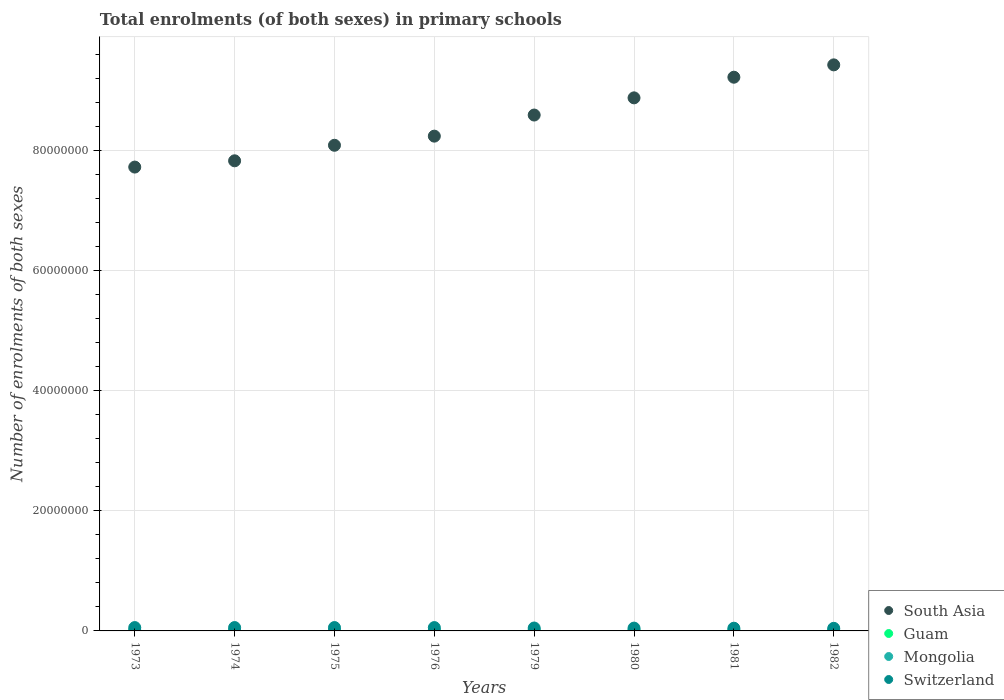How many different coloured dotlines are there?
Keep it short and to the point. 4. Is the number of dotlines equal to the number of legend labels?
Your answer should be very brief. Yes. What is the number of enrolments in primary schools in Switzerland in 1979?
Make the answer very short. 4.86e+05. Across all years, what is the maximum number of enrolments in primary schools in Switzerland?
Provide a short and direct response. 5.62e+05. Across all years, what is the minimum number of enrolments in primary schools in South Asia?
Provide a succinct answer. 7.73e+07. In which year was the number of enrolments in primary schools in Guam maximum?
Offer a very short reply. 1976. What is the total number of enrolments in primary schools in Guam in the graph?
Provide a short and direct response. 1.47e+05. What is the difference between the number of enrolments in primary schools in Switzerland in 1979 and that in 1981?
Your answer should be compact. 3.50e+04. What is the difference between the number of enrolments in primary schools in Guam in 1973 and the number of enrolments in primary schools in Switzerland in 1982?
Offer a very short reply. -4.16e+05. What is the average number of enrolments in primary schools in Guam per year?
Provide a succinct answer. 1.84e+04. In the year 1975, what is the difference between the number of enrolments in primary schools in Guam and number of enrolments in primary schools in Mongolia?
Ensure brevity in your answer.  -1.10e+05. What is the ratio of the number of enrolments in primary schools in Switzerland in 1974 to that in 1979?
Ensure brevity in your answer.  1.16. Is the number of enrolments in primary schools in Guam in 1974 less than that in 1976?
Your answer should be very brief. Yes. Is the difference between the number of enrolments in primary schools in Guam in 1974 and 1981 greater than the difference between the number of enrolments in primary schools in Mongolia in 1974 and 1981?
Offer a very short reply. Yes. What is the difference between the highest and the second highest number of enrolments in primary schools in Switzerland?
Your answer should be very brief. 128. What is the difference between the highest and the lowest number of enrolments in primary schools in Switzerland?
Offer a very short reply. 1.27e+05. In how many years, is the number of enrolments in primary schools in Guam greater than the average number of enrolments in primary schools in Guam taken over all years?
Offer a very short reply. 3. Is the sum of the number of enrolments in primary schools in Guam in 1973 and 1975 greater than the maximum number of enrolments in primary schools in Mongolia across all years?
Make the answer very short. No. Is it the case that in every year, the sum of the number of enrolments in primary schools in Guam and number of enrolments in primary schools in Mongolia  is greater than the sum of number of enrolments in primary schools in South Asia and number of enrolments in primary schools in Switzerland?
Your response must be concise. No. Is the number of enrolments in primary schools in Guam strictly less than the number of enrolments in primary schools in Switzerland over the years?
Offer a very short reply. Yes. Does the graph contain any zero values?
Your response must be concise. No. Does the graph contain grids?
Make the answer very short. Yes. Where does the legend appear in the graph?
Ensure brevity in your answer.  Bottom right. How many legend labels are there?
Ensure brevity in your answer.  4. What is the title of the graph?
Provide a short and direct response. Total enrolments (of both sexes) in primary schools. Does "European Union" appear as one of the legend labels in the graph?
Give a very brief answer. No. What is the label or title of the Y-axis?
Ensure brevity in your answer.  Number of enrolments of both sexes. What is the Number of enrolments of both sexes in South Asia in 1973?
Your response must be concise. 7.73e+07. What is the Number of enrolments of both sexes of Guam in 1973?
Your answer should be very brief. 1.87e+04. What is the Number of enrolments of both sexes in Mongolia in 1973?
Give a very brief answer. 1.25e+05. What is the Number of enrolments of both sexes in Switzerland in 1973?
Your response must be concise. 5.58e+05. What is the Number of enrolments of both sexes in South Asia in 1974?
Provide a succinct answer. 7.83e+07. What is the Number of enrolments of both sexes of Guam in 1974?
Provide a succinct answer. 1.85e+04. What is the Number of enrolments of both sexes in Mongolia in 1974?
Keep it short and to the point. 1.27e+05. What is the Number of enrolments of both sexes in Switzerland in 1974?
Provide a short and direct response. 5.62e+05. What is the Number of enrolments of both sexes in South Asia in 1975?
Provide a short and direct response. 8.09e+07. What is the Number of enrolments of both sexes in Guam in 1975?
Provide a succinct answer. 1.78e+04. What is the Number of enrolments of both sexes of Mongolia in 1975?
Provide a short and direct response. 1.28e+05. What is the Number of enrolments of both sexes in Switzerland in 1975?
Keep it short and to the point. 5.62e+05. What is the Number of enrolments of both sexes in South Asia in 1976?
Ensure brevity in your answer.  8.24e+07. What is the Number of enrolments of both sexes in Guam in 1976?
Provide a succinct answer. 2.02e+04. What is the Number of enrolments of both sexes of Mongolia in 1976?
Your response must be concise. 1.30e+05. What is the Number of enrolments of both sexes of Switzerland in 1976?
Your answer should be very brief. 5.57e+05. What is the Number of enrolments of both sexes in South Asia in 1979?
Provide a short and direct response. 8.59e+07. What is the Number of enrolments of both sexes in Guam in 1979?
Provide a succinct answer. 1.77e+04. What is the Number of enrolments of both sexes of Mongolia in 1979?
Provide a succinct answer. 1.39e+05. What is the Number of enrolments of both sexes in Switzerland in 1979?
Provide a short and direct response. 4.86e+05. What is the Number of enrolments of both sexes of South Asia in 1980?
Provide a short and direct response. 8.88e+07. What is the Number of enrolments of both sexes in Guam in 1980?
Your answer should be compact. 1.80e+04. What is the Number of enrolments of both sexes in Mongolia in 1980?
Your answer should be compact. 1.41e+05. What is the Number of enrolments of both sexes of Switzerland in 1980?
Your answer should be compact. 4.69e+05. What is the Number of enrolments of both sexes of South Asia in 1981?
Give a very brief answer. 9.22e+07. What is the Number of enrolments of both sexes in Guam in 1981?
Your response must be concise. 1.81e+04. What is the Number of enrolments of both sexes of Mongolia in 1981?
Offer a terse response. 1.45e+05. What is the Number of enrolments of both sexes of Switzerland in 1981?
Your response must be concise. 4.51e+05. What is the Number of enrolments of both sexes in South Asia in 1982?
Provide a short and direct response. 9.43e+07. What is the Number of enrolments of both sexes in Guam in 1982?
Offer a terse response. 1.79e+04. What is the Number of enrolments of both sexes of Mongolia in 1982?
Ensure brevity in your answer.  1.46e+05. What is the Number of enrolments of both sexes of Switzerland in 1982?
Make the answer very short. 4.34e+05. Across all years, what is the maximum Number of enrolments of both sexes in South Asia?
Provide a succinct answer. 9.43e+07. Across all years, what is the maximum Number of enrolments of both sexes of Guam?
Ensure brevity in your answer.  2.02e+04. Across all years, what is the maximum Number of enrolments of both sexes of Mongolia?
Provide a succinct answer. 1.46e+05. Across all years, what is the maximum Number of enrolments of both sexes in Switzerland?
Offer a very short reply. 5.62e+05. Across all years, what is the minimum Number of enrolments of both sexes of South Asia?
Your answer should be very brief. 7.73e+07. Across all years, what is the minimum Number of enrolments of both sexes of Guam?
Offer a very short reply. 1.77e+04. Across all years, what is the minimum Number of enrolments of both sexes in Mongolia?
Make the answer very short. 1.25e+05. Across all years, what is the minimum Number of enrolments of both sexes of Switzerland?
Offer a very short reply. 4.34e+05. What is the total Number of enrolments of both sexes of South Asia in the graph?
Offer a terse response. 6.80e+08. What is the total Number of enrolments of both sexes in Guam in the graph?
Keep it short and to the point. 1.47e+05. What is the total Number of enrolments of both sexes in Mongolia in the graph?
Your answer should be very brief. 1.08e+06. What is the total Number of enrolments of both sexes of Switzerland in the graph?
Ensure brevity in your answer.  4.08e+06. What is the difference between the Number of enrolments of both sexes in South Asia in 1973 and that in 1974?
Offer a terse response. -1.05e+06. What is the difference between the Number of enrolments of both sexes in Guam in 1973 and that in 1974?
Offer a terse response. 196. What is the difference between the Number of enrolments of both sexes in Mongolia in 1973 and that in 1974?
Give a very brief answer. -1900. What is the difference between the Number of enrolments of both sexes of Switzerland in 1973 and that in 1974?
Your answer should be very brief. -3917. What is the difference between the Number of enrolments of both sexes in South Asia in 1973 and that in 1975?
Your answer should be very brief. -3.63e+06. What is the difference between the Number of enrolments of both sexes of Guam in 1973 and that in 1975?
Your answer should be very brief. 862. What is the difference between the Number of enrolments of both sexes of Mongolia in 1973 and that in 1975?
Offer a very short reply. -2786. What is the difference between the Number of enrolments of both sexes of Switzerland in 1973 and that in 1975?
Offer a terse response. -3789. What is the difference between the Number of enrolments of both sexes of South Asia in 1973 and that in 1976?
Provide a short and direct response. -5.15e+06. What is the difference between the Number of enrolments of both sexes of Guam in 1973 and that in 1976?
Make the answer very short. -1542. What is the difference between the Number of enrolments of both sexes of Mongolia in 1973 and that in 1976?
Your answer should be very brief. -4602. What is the difference between the Number of enrolments of both sexes of Switzerland in 1973 and that in 1976?
Your answer should be very brief. 971. What is the difference between the Number of enrolments of both sexes of South Asia in 1973 and that in 1979?
Your response must be concise. -8.67e+06. What is the difference between the Number of enrolments of both sexes in Guam in 1973 and that in 1979?
Offer a very short reply. 929. What is the difference between the Number of enrolments of both sexes of Mongolia in 1973 and that in 1979?
Give a very brief answer. -1.35e+04. What is the difference between the Number of enrolments of both sexes of Switzerland in 1973 and that in 1979?
Offer a very short reply. 7.20e+04. What is the difference between the Number of enrolments of both sexes of South Asia in 1973 and that in 1980?
Your response must be concise. -1.15e+07. What is the difference between the Number of enrolments of both sexes of Guam in 1973 and that in 1980?
Offer a terse response. 636. What is the difference between the Number of enrolments of both sexes in Mongolia in 1973 and that in 1980?
Offer a very short reply. -1.61e+04. What is the difference between the Number of enrolments of both sexes in Switzerland in 1973 and that in 1980?
Your response must be concise. 8.93e+04. What is the difference between the Number of enrolments of both sexes of South Asia in 1973 and that in 1981?
Keep it short and to the point. -1.50e+07. What is the difference between the Number of enrolments of both sexes of Guam in 1973 and that in 1981?
Provide a short and direct response. 580. What is the difference between the Number of enrolments of both sexes of Switzerland in 1973 and that in 1981?
Provide a succinct answer. 1.07e+05. What is the difference between the Number of enrolments of both sexes in South Asia in 1973 and that in 1982?
Offer a terse response. -1.70e+07. What is the difference between the Number of enrolments of both sexes in Guam in 1973 and that in 1982?
Your answer should be compact. 728. What is the difference between the Number of enrolments of both sexes of Mongolia in 1973 and that in 1982?
Give a very brief answer. -2.13e+04. What is the difference between the Number of enrolments of both sexes in Switzerland in 1973 and that in 1982?
Ensure brevity in your answer.  1.24e+05. What is the difference between the Number of enrolments of both sexes of South Asia in 1974 and that in 1975?
Provide a succinct answer. -2.59e+06. What is the difference between the Number of enrolments of both sexes in Guam in 1974 and that in 1975?
Offer a very short reply. 666. What is the difference between the Number of enrolments of both sexes in Mongolia in 1974 and that in 1975?
Your answer should be very brief. -886. What is the difference between the Number of enrolments of both sexes of Switzerland in 1974 and that in 1975?
Ensure brevity in your answer.  128. What is the difference between the Number of enrolments of both sexes in South Asia in 1974 and that in 1976?
Give a very brief answer. -4.11e+06. What is the difference between the Number of enrolments of both sexes of Guam in 1974 and that in 1976?
Provide a short and direct response. -1738. What is the difference between the Number of enrolments of both sexes of Mongolia in 1974 and that in 1976?
Provide a succinct answer. -2702. What is the difference between the Number of enrolments of both sexes in Switzerland in 1974 and that in 1976?
Provide a succinct answer. 4888. What is the difference between the Number of enrolments of both sexes in South Asia in 1974 and that in 1979?
Offer a very short reply. -7.62e+06. What is the difference between the Number of enrolments of both sexes of Guam in 1974 and that in 1979?
Your response must be concise. 733. What is the difference between the Number of enrolments of both sexes of Mongolia in 1974 and that in 1979?
Ensure brevity in your answer.  -1.16e+04. What is the difference between the Number of enrolments of both sexes of Switzerland in 1974 and that in 1979?
Provide a short and direct response. 7.59e+04. What is the difference between the Number of enrolments of both sexes in South Asia in 1974 and that in 1980?
Offer a terse response. -1.05e+07. What is the difference between the Number of enrolments of both sexes of Guam in 1974 and that in 1980?
Offer a very short reply. 440. What is the difference between the Number of enrolments of both sexes in Mongolia in 1974 and that in 1980?
Offer a very short reply. -1.42e+04. What is the difference between the Number of enrolments of both sexes of Switzerland in 1974 and that in 1980?
Make the answer very short. 9.32e+04. What is the difference between the Number of enrolments of both sexes of South Asia in 1974 and that in 1981?
Provide a succinct answer. -1.39e+07. What is the difference between the Number of enrolments of both sexes in Guam in 1974 and that in 1981?
Your answer should be compact. 384. What is the difference between the Number of enrolments of both sexes of Mongolia in 1974 and that in 1981?
Provide a succinct answer. -1.81e+04. What is the difference between the Number of enrolments of both sexes in Switzerland in 1974 and that in 1981?
Your answer should be very brief. 1.11e+05. What is the difference between the Number of enrolments of both sexes of South Asia in 1974 and that in 1982?
Offer a terse response. -1.60e+07. What is the difference between the Number of enrolments of both sexes of Guam in 1974 and that in 1982?
Offer a terse response. 532. What is the difference between the Number of enrolments of both sexes of Mongolia in 1974 and that in 1982?
Provide a succinct answer. -1.94e+04. What is the difference between the Number of enrolments of both sexes in Switzerland in 1974 and that in 1982?
Provide a short and direct response. 1.27e+05. What is the difference between the Number of enrolments of both sexes in South Asia in 1975 and that in 1976?
Provide a short and direct response. -1.52e+06. What is the difference between the Number of enrolments of both sexes of Guam in 1975 and that in 1976?
Provide a succinct answer. -2404. What is the difference between the Number of enrolments of both sexes of Mongolia in 1975 and that in 1976?
Offer a terse response. -1816. What is the difference between the Number of enrolments of both sexes in Switzerland in 1975 and that in 1976?
Your answer should be very brief. 4760. What is the difference between the Number of enrolments of both sexes of South Asia in 1975 and that in 1979?
Your answer should be very brief. -5.04e+06. What is the difference between the Number of enrolments of both sexes of Guam in 1975 and that in 1979?
Make the answer very short. 67. What is the difference between the Number of enrolments of both sexes in Mongolia in 1975 and that in 1979?
Keep it short and to the point. -1.07e+04. What is the difference between the Number of enrolments of both sexes of Switzerland in 1975 and that in 1979?
Make the answer very short. 7.57e+04. What is the difference between the Number of enrolments of both sexes in South Asia in 1975 and that in 1980?
Give a very brief answer. -7.90e+06. What is the difference between the Number of enrolments of both sexes in Guam in 1975 and that in 1980?
Provide a short and direct response. -226. What is the difference between the Number of enrolments of both sexes in Mongolia in 1975 and that in 1980?
Give a very brief answer. -1.33e+04. What is the difference between the Number of enrolments of both sexes of Switzerland in 1975 and that in 1980?
Ensure brevity in your answer.  9.31e+04. What is the difference between the Number of enrolments of both sexes in South Asia in 1975 and that in 1981?
Give a very brief answer. -1.13e+07. What is the difference between the Number of enrolments of both sexes in Guam in 1975 and that in 1981?
Make the answer very short. -282. What is the difference between the Number of enrolments of both sexes in Mongolia in 1975 and that in 1981?
Keep it short and to the point. -1.72e+04. What is the difference between the Number of enrolments of both sexes of Switzerland in 1975 and that in 1981?
Offer a very short reply. 1.11e+05. What is the difference between the Number of enrolments of both sexes of South Asia in 1975 and that in 1982?
Ensure brevity in your answer.  -1.34e+07. What is the difference between the Number of enrolments of both sexes in Guam in 1975 and that in 1982?
Provide a short and direct response. -134. What is the difference between the Number of enrolments of both sexes of Mongolia in 1975 and that in 1982?
Make the answer very short. -1.85e+04. What is the difference between the Number of enrolments of both sexes of Switzerland in 1975 and that in 1982?
Your answer should be compact. 1.27e+05. What is the difference between the Number of enrolments of both sexes of South Asia in 1976 and that in 1979?
Provide a short and direct response. -3.52e+06. What is the difference between the Number of enrolments of both sexes of Guam in 1976 and that in 1979?
Your answer should be very brief. 2471. What is the difference between the Number of enrolments of both sexes of Mongolia in 1976 and that in 1979?
Your answer should be very brief. -8873. What is the difference between the Number of enrolments of both sexes in Switzerland in 1976 and that in 1979?
Your answer should be very brief. 7.10e+04. What is the difference between the Number of enrolments of both sexes in South Asia in 1976 and that in 1980?
Give a very brief answer. -6.38e+06. What is the difference between the Number of enrolments of both sexes in Guam in 1976 and that in 1980?
Give a very brief answer. 2178. What is the difference between the Number of enrolments of both sexes in Mongolia in 1976 and that in 1980?
Your response must be concise. -1.15e+04. What is the difference between the Number of enrolments of both sexes in Switzerland in 1976 and that in 1980?
Your answer should be compact. 8.84e+04. What is the difference between the Number of enrolments of both sexes of South Asia in 1976 and that in 1981?
Your response must be concise. -9.82e+06. What is the difference between the Number of enrolments of both sexes of Guam in 1976 and that in 1981?
Make the answer very short. 2122. What is the difference between the Number of enrolments of both sexes in Mongolia in 1976 and that in 1981?
Your answer should be compact. -1.54e+04. What is the difference between the Number of enrolments of both sexes in Switzerland in 1976 and that in 1981?
Give a very brief answer. 1.06e+05. What is the difference between the Number of enrolments of both sexes of South Asia in 1976 and that in 1982?
Offer a very short reply. -1.19e+07. What is the difference between the Number of enrolments of both sexes of Guam in 1976 and that in 1982?
Provide a short and direct response. 2270. What is the difference between the Number of enrolments of both sexes in Mongolia in 1976 and that in 1982?
Your answer should be very brief. -1.67e+04. What is the difference between the Number of enrolments of both sexes of Switzerland in 1976 and that in 1982?
Give a very brief answer. 1.23e+05. What is the difference between the Number of enrolments of both sexes in South Asia in 1979 and that in 1980?
Make the answer very short. -2.86e+06. What is the difference between the Number of enrolments of both sexes in Guam in 1979 and that in 1980?
Give a very brief answer. -293. What is the difference between the Number of enrolments of both sexes of Mongolia in 1979 and that in 1980?
Provide a short and direct response. -2631. What is the difference between the Number of enrolments of both sexes in Switzerland in 1979 and that in 1980?
Your answer should be compact. 1.74e+04. What is the difference between the Number of enrolments of both sexes of South Asia in 1979 and that in 1981?
Provide a short and direct response. -6.30e+06. What is the difference between the Number of enrolments of both sexes in Guam in 1979 and that in 1981?
Your answer should be very brief. -349. What is the difference between the Number of enrolments of both sexes in Mongolia in 1979 and that in 1981?
Offer a very short reply. -6525. What is the difference between the Number of enrolments of both sexes of Switzerland in 1979 and that in 1981?
Make the answer very short. 3.50e+04. What is the difference between the Number of enrolments of both sexes in South Asia in 1979 and that in 1982?
Keep it short and to the point. -8.36e+06. What is the difference between the Number of enrolments of both sexes in Guam in 1979 and that in 1982?
Make the answer very short. -201. What is the difference between the Number of enrolments of both sexes in Mongolia in 1979 and that in 1982?
Your response must be concise. -7825. What is the difference between the Number of enrolments of both sexes in Switzerland in 1979 and that in 1982?
Keep it short and to the point. 5.16e+04. What is the difference between the Number of enrolments of both sexes of South Asia in 1980 and that in 1981?
Provide a succinct answer. -3.44e+06. What is the difference between the Number of enrolments of both sexes of Guam in 1980 and that in 1981?
Your answer should be very brief. -56. What is the difference between the Number of enrolments of both sexes of Mongolia in 1980 and that in 1981?
Keep it short and to the point. -3894. What is the difference between the Number of enrolments of both sexes of Switzerland in 1980 and that in 1981?
Your answer should be very brief. 1.76e+04. What is the difference between the Number of enrolments of both sexes in South Asia in 1980 and that in 1982?
Your answer should be very brief. -5.50e+06. What is the difference between the Number of enrolments of both sexes in Guam in 1980 and that in 1982?
Offer a terse response. 92. What is the difference between the Number of enrolments of both sexes of Mongolia in 1980 and that in 1982?
Keep it short and to the point. -5194. What is the difference between the Number of enrolments of both sexes of Switzerland in 1980 and that in 1982?
Your response must be concise. 3.42e+04. What is the difference between the Number of enrolments of both sexes in South Asia in 1981 and that in 1982?
Make the answer very short. -2.06e+06. What is the difference between the Number of enrolments of both sexes of Guam in 1981 and that in 1982?
Ensure brevity in your answer.  148. What is the difference between the Number of enrolments of both sexes of Mongolia in 1981 and that in 1982?
Keep it short and to the point. -1300. What is the difference between the Number of enrolments of both sexes in Switzerland in 1981 and that in 1982?
Keep it short and to the point. 1.67e+04. What is the difference between the Number of enrolments of both sexes in South Asia in 1973 and the Number of enrolments of both sexes in Guam in 1974?
Give a very brief answer. 7.73e+07. What is the difference between the Number of enrolments of both sexes of South Asia in 1973 and the Number of enrolments of both sexes of Mongolia in 1974?
Keep it short and to the point. 7.71e+07. What is the difference between the Number of enrolments of both sexes in South Asia in 1973 and the Number of enrolments of both sexes in Switzerland in 1974?
Your response must be concise. 7.67e+07. What is the difference between the Number of enrolments of both sexes of Guam in 1973 and the Number of enrolments of both sexes of Mongolia in 1974?
Keep it short and to the point. -1.08e+05. What is the difference between the Number of enrolments of both sexes in Guam in 1973 and the Number of enrolments of both sexes in Switzerland in 1974?
Your response must be concise. -5.43e+05. What is the difference between the Number of enrolments of both sexes in Mongolia in 1973 and the Number of enrolments of both sexes in Switzerland in 1974?
Give a very brief answer. -4.37e+05. What is the difference between the Number of enrolments of both sexes of South Asia in 1973 and the Number of enrolments of both sexes of Guam in 1975?
Your answer should be compact. 7.73e+07. What is the difference between the Number of enrolments of both sexes of South Asia in 1973 and the Number of enrolments of both sexes of Mongolia in 1975?
Give a very brief answer. 7.71e+07. What is the difference between the Number of enrolments of both sexes in South Asia in 1973 and the Number of enrolments of both sexes in Switzerland in 1975?
Provide a short and direct response. 7.67e+07. What is the difference between the Number of enrolments of both sexes of Guam in 1973 and the Number of enrolments of both sexes of Mongolia in 1975?
Offer a very short reply. -1.09e+05. What is the difference between the Number of enrolments of both sexes of Guam in 1973 and the Number of enrolments of both sexes of Switzerland in 1975?
Offer a very short reply. -5.43e+05. What is the difference between the Number of enrolments of both sexes of Mongolia in 1973 and the Number of enrolments of both sexes of Switzerland in 1975?
Give a very brief answer. -4.36e+05. What is the difference between the Number of enrolments of both sexes of South Asia in 1973 and the Number of enrolments of both sexes of Guam in 1976?
Your answer should be compact. 7.73e+07. What is the difference between the Number of enrolments of both sexes of South Asia in 1973 and the Number of enrolments of both sexes of Mongolia in 1976?
Your answer should be compact. 7.71e+07. What is the difference between the Number of enrolments of both sexes of South Asia in 1973 and the Number of enrolments of both sexes of Switzerland in 1976?
Give a very brief answer. 7.67e+07. What is the difference between the Number of enrolments of both sexes of Guam in 1973 and the Number of enrolments of both sexes of Mongolia in 1976?
Offer a terse response. -1.11e+05. What is the difference between the Number of enrolments of both sexes of Guam in 1973 and the Number of enrolments of both sexes of Switzerland in 1976?
Your answer should be compact. -5.38e+05. What is the difference between the Number of enrolments of both sexes of Mongolia in 1973 and the Number of enrolments of both sexes of Switzerland in 1976?
Offer a terse response. -4.32e+05. What is the difference between the Number of enrolments of both sexes of South Asia in 1973 and the Number of enrolments of both sexes of Guam in 1979?
Keep it short and to the point. 7.73e+07. What is the difference between the Number of enrolments of both sexes in South Asia in 1973 and the Number of enrolments of both sexes in Mongolia in 1979?
Keep it short and to the point. 7.71e+07. What is the difference between the Number of enrolments of both sexes of South Asia in 1973 and the Number of enrolments of both sexes of Switzerland in 1979?
Make the answer very short. 7.68e+07. What is the difference between the Number of enrolments of both sexes in Guam in 1973 and the Number of enrolments of both sexes in Mongolia in 1979?
Keep it short and to the point. -1.20e+05. What is the difference between the Number of enrolments of both sexes of Guam in 1973 and the Number of enrolments of both sexes of Switzerland in 1979?
Your answer should be very brief. -4.67e+05. What is the difference between the Number of enrolments of both sexes of Mongolia in 1973 and the Number of enrolments of both sexes of Switzerland in 1979?
Offer a terse response. -3.61e+05. What is the difference between the Number of enrolments of both sexes in South Asia in 1973 and the Number of enrolments of both sexes in Guam in 1980?
Make the answer very short. 7.73e+07. What is the difference between the Number of enrolments of both sexes of South Asia in 1973 and the Number of enrolments of both sexes of Mongolia in 1980?
Offer a terse response. 7.71e+07. What is the difference between the Number of enrolments of both sexes of South Asia in 1973 and the Number of enrolments of both sexes of Switzerland in 1980?
Give a very brief answer. 7.68e+07. What is the difference between the Number of enrolments of both sexes in Guam in 1973 and the Number of enrolments of both sexes in Mongolia in 1980?
Offer a very short reply. -1.23e+05. What is the difference between the Number of enrolments of both sexes in Guam in 1973 and the Number of enrolments of both sexes in Switzerland in 1980?
Provide a succinct answer. -4.50e+05. What is the difference between the Number of enrolments of both sexes in Mongolia in 1973 and the Number of enrolments of both sexes in Switzerland in 1980?
Your answer should be very brief. -3.43e+05. What is the difference between the Number of enrolments of both sexes of South Asia in 1973 and the Number of enrolments of both sexes of Guam in 1981?
Your response must be concise. 7.73e+07. What is the difference between the Number of enrolments of both sexes of South Asia in 1973 and the Number of enrolments of both sexes of Mongolia in 1981?
Your answer should be compact. 7.71e+07. What is the difference between the Number of enrolments of both sexes of South Asia in 1973 and the Number of enrolments of both sexes of Switzerland in 1981?
Offer a terse response. 7.68e+07. What is the difference between the Number of enrolments of both sexes of Guam in 1973 and the Number of enrolments of both sexes of Mongolia in 1981?
Provide a succinct answer. -1.27e+05. What is the difference between the Number of enrolments of both sexes in Guam in 1973 and the Number of enrolments of both sexes in Switzerland in 1981?
Ensure brevity in your answer.  -4.32e+05. What is the difference between the Number of enrolments of both sexes in Mongolia in 1973 and the Number of enrolments of both sexes in Switzerland in 1981?
Make the answer very short. -3.26e+05. What is the difference between the Number of enrolments of both sexes in South Asia in 1973 and the Number of enrolments of both sexes in Guam in 1982?
Make the answer very short. 7.73e+07. What is the difference between the Number of enrolments of both sexes in South Asia in 1973 and the Number of enrolments of both sexes in Mongolia in 1982?
Ensure brevity in your answer.  7.71e+07. What is the difference between the Number of enrolments of both sexes of South Asia in 1973 and the Number of enrolments of both sexes of Switzerland in 1982?
Your response must be concise. 7.68e+07. What is the difference between the Number of enrolments of both sexes in Guam in 1973 and the Number of enrolments of both sexes in Mongolia in 1982?
Provide a succinct answer. -1.28e+05. What is the difference between the Number of enrolments of both sexes of Guam in 1973 and the Number of enrolments of both sexes of Switzerland in 1982?
Give a very brief answer. -4.16e+05. What is the difference between the Number of enrolments of both sexes in Mongolia in 1973 and the Number of enrolments of both sexes in Switzerland in 1982?
Provide a short and direct response. -3.09e+05. What is the difference between the Number of enrolments of both sexes in South Asia in 1974 and the Number of enrolments of both sexes in Guam in 1975?
Give a very brief answer. 7.83e+07. What is the difference between the Number of enrolments of both sexes of South Asia in 1974 and the Number of enrolments of both sexes of Mongolia in 1975?
Offer a terse response. 7.82e+07. What is the difference between the Number of enrolments of both sexes in South Asia in 1974 and the Number of enrolments of both sexes in Switzerland in 1975?
Offer a terse response. 7.78e+07. What is the difference between the Number of enrolments of both sexes of Guam in 1974 and the Number of enrolments of both sexes of Mongolia in 1975?
Keep it short and to the point. -1.10e+05. What is the difference between the Number of enrolments of both sexes in Guam in 1974 and the Number of enrolments of both sexes in Switzerland in 1975?
Offer a terse response. -5.43e+05. What is the difference between the Number of enrolments of both sexes of Mongolia in 1974 and the Number of enrolments of both sexes of Switzerland in 1975?
Your answer should be very brief. -4.35e+05. What is the difference between the Number of enrolments of both sexes in South Asia in 1974 and the Number of enrolments of both sexes in Guam in 1976?
Provide a short and direct response. 7.83e+07. What is the difference between the Number of enrolments of both sexes in South Asia in 1974 and the Number of enrolments of both sexes in Mongolia in 1976?
Make the answer very short. 7.82e+07. What is the difference between the Number of enrolments of both sexes in South Asia in 1974 and the Number of enrolments of both sexes in Switzerland in 1976?
Give a very brief answer. 7.78e+07. What is the difference between the Number of enrolments of both sexes in Guam in 1974 and the Number of enrolments of both sexes in Mongolia in 1976?
Offer a very short reply. -1.11e+05. What is the difference between the Number of enrolments of both sexes of Guam in 1974 and the Number of enrolments of both sexes of Switzerland in 1976?
Give a very brief answer. -5.38e+05. What is the difference between the Number of enrolments of both sexes in Mongolia in 1974 and the Number of enrolments of both sexes in Switzerland in 1976?
Offer a terse response. -4.30e+05. What is the difference between the Number of enrolments of both sexes of South Asia in 1974 and the Number of enrolments of both sexes of Guam in 1979?
Offer a terse response. 7.83e+07. What is the difference between the Number of enrolments of both sexes in South Asia in 1974 and the Number of enrolments of both sexes in Mongolia in 1979?
Offer a very short reply. 7.82e+07. What is the difference between the Number of enrolments of both sexes of South Asia in 1974 and the Number of enrolments of both sexes of Switzerland in 1979?
Ensure brevity in your answer.  7.78e+07. What is the difference between the Number of enrolments of both sexes of Guam in 1974 and the Number of enrolments of both sexes of Mongolia in 1979?
Offer a very short reply. -1.20e+05. What is the difference between the Number of enrolments of both sexes of Guam in 1974 and the Number of enrolments of both sexes of Switzerland in 1979?
Give a very brief answer. -4.67e+05. What is the difference between the Number of enrolments of both sexes in Mongolia in 1974 and the Number of enrolments of both sexes in Switzerland in 1979?
Offer a terse response. -3.59e+05. What is the difference between the Number of enrolments of both sexes in South Asia in 1974 and the Number of enrolments of both sexes in Guam in 1980?
Offer a terse response. 7.83e+07. What is the difference between the Number of enrolments of both sexes in South Asia in 1974 and the Number of enrolments of both sexes in Mongolia in 1980?
Give a very brief answer. 7.82e+07. What is the difference between the Number of enrolments of both sexes of South Asia in 1974 and the Number of enrolments of both sexes of Switzerland in 1980?
Give a very brief answer. 7.79e+07. What is the difference between the Number of enrolments of both sexes of Guam in 1974 and the Number of enrolments of both sexes of Mongolia in 1980?
Offer a terse response. -1.23e+05. What is the difference between the Number of enrolments of both sexes of Guam in 1974 and the Number of enrolments of both sexes of Switzerland in 1980?
Provide a short and direct response. -4.50e+05. What is the difference between the Number of enrolments of both sexes in Mongolia in 1974 and the Number of enrolments of both sexes in Switzerland in 1980?
Ensure brevity in your answer.  -3.41e+05. What is the difference between the Number of enrolments of both sexes in South Asia in 1974 and the Number of enrolments of both sexes in Guam in 1981?
Give a very brief answer. 7.83e+07. What is the difference between the Number of enrolments of both sexes of South Asia in 1974 and the Number of enrolments of both sexes of Mongolia in 1981?
Provide a short and direct response. 7.82e+07. What is the difference between the Number of enrolments of both sexes in South Asia in 1974 and the Number of enrolments of both sexes in Switzerland in 1981?
Make the answer very short. 7.79e+07. What is the difference between the Number of enrolments of both sexes of Guam in 1974 and the Number of enrolments of both sexes of Mongolia in 1981?
Your answer should be compact. -1.27e+05. What is the difference between the Number of enrolments of both sexes of Guam in 1974 and the Number of enrolments of both sexes of Switzerland in 1981?
Ensure brevity in your answer.  -4.32e+05. What is the difference between the Number of enrolments of both sexes in Mongolia in 1974 and the Number of enrolments of both sexes in Switzerland in 1981?
Your answer should be very brief. -3.24e+05. What is the difference between the Number of enrolments of both sexes in South Asia in 1974 and the Number of enrolments of both sexes in Guam in 1982?
Offer a very short reply. 7.83e+07. What is the difference between the Number of enrolments of both sexes of South Asia in 1974 and the Number of enrolments of both sexes of Mongolia in 1982?
Offer a terse response. 7.82e+07. What is the difference between the Number of enrolments of both sexes of South Asia in 1974 and the Number of enrolments of both sexes of Switzerland in 1982?
Give a very brief answer. 7.79e+07. What is the difference between the Number of enrolments of both sexes in Guam in 1974 and the Number of enrolments of both sexes in Mongolia in 1982?
Offer a very short reply. -1.28e+05. What is the difference between the Number of enrolments of both sexes in Guam in 1974 and the Number of enrolments of both sexes in Switzerland in 1982?
Ensure brevity in your answer.  -4.16e+05. What is the difference between the Number of enrolments of both sexes in Mongolia in 1974 and the Number of enrolments of both sexes in Switzerland in 1982?
Make the answer very short. -3.07e+05. What is the difference between the Number of enrolments of both sexes of South Asia in 1975 and the Number of enrolments of both sexes of Guam in 1976?
Offer a very short reply. 8.09e+07. What is the difference between the Number of enrolments of both sexes in South Asia in 1975 and the Number of enrolments of both sexes in Mongolia in 1976?
Provide a succinct answer. 8.08e+07. What is the difference between the Number of enrolments of both sexes in South Asia in 1975 and the Number of enrolments of both sexes in Switzerland in 1976?
Your answer should be compact. 8.04e+07. What is the difference between the Number of enrolments of both sexes of Guam in 1975 and the Number of enrolments of both sexes of Mongolia in 1976?
Your answer should be compact. -1.12e+05. What is the difference between the Number of enrolments of both sexes of Guam in 1975 and the Number of enrolments of both sexes of Switzerland in 1976?
Ensure brevity in your answer.  -5.39e+05. What is the difference between the Number of enrolments of both sexes in Mongolia in 1975 and the Number of enrolments of both sexes in Switzerland in 1976?
Offer a very short reply. -4.29e+05. What is the difference between the Number of enrolments of both sexes in South Asia in 1975 and the Number of enrolments of both sexes in Guam in 1979?
Provide a succinct answer. 8.09e+07. What is the difference between the Number of enrolments of both sexes of South Asia in 1975 and the Number of enrolments of both sexes of Mongolia in 1979?
Your answer should be compact. 8.08e+07. What is the difference between the Number of enrolments of both sexes of South Asia in 1975 and the Number of enrolments of both sexes of Switzerland in 1979?
Offer a terse response. 8.04e+07. What is the difference between the Number of enrolments of both sexes of Guam in 1975 and the Number of enrolments of both sexes of Mongolia in 1979?
Offer a very short reply. -1.21e+05. What is the difference between the Number of enrolments of both sexes in Guam in 1975 and the Number of enrolments of both sexes in Switzerland in 1979?
Your answer should be compact. -4.68e+05. What is the difference between the Number of enrolments of both sexes in Mongolia in 1975 and the Number of enrolments of both sexes in Switzerland in 1979?
Your response must be concise. -3.58e+05. What is the difference between the Number of enrolments of both sexes in South Asia in 1975 and the Number of enrolments of both sexes in Guam in 1980?
Your answer should be compact. 8.09e+07. What is the difference between the Number of enrolments of both sexes of South Asia in 1975 and the Number of enrolments of both sexes of Mongolia in 1980?
Offer a very short reply. 8.08e+07. What is the difference between the Number of enrolments of both sexes of South Asia in 1975 and the Number of enrolments of both sexes of Switzerland in 1980?
Your response must be concise. 8.04e+07. What is the difference between the Number of enrolments of both sexes of Guam in 1975 and the Number of enrolments of both sexes of Mongolia in 1980?
Your answer should be very brief. -1.23e+05. What is the difference between the Number of enrolments of both sexes in Guam in 1975 and the Number of enrolments of both sexes in Switzerland in 1980?
Provide a succinct answer. -4.51e+05. What is the difference between the Number of enrolments of both sexes in Mongolia in 1975 and the Number of enrolments of both sexes in Switzerland in 1980?
Make the answer very short. -3.41e+05. What is the difference between the Number of enrolments of both sexes in South Asia in 1975 and the Number of enrolments of both sexes in Guam in 1981?
Provide a succinct answer. 8.09e+07. What is the difference between the Number of enrolments of both sexes of South Asia in 1975 and the Number of enrolments of both sexes of Mongolia in 1981?
Keep it short and to the point. 8.08e+07. What is the difference between the Number of enrolments of both sexes of South Asia in 1975 and the Number of enrolments of both sexes of Switzerland in 1981?
Offer a terse response. 8.05e+07. What is the difference between the Number of enrolments of both sexes of Guam in 1975 and the Number of enrolments of both sexes of Mongolia in 1981?
Make the answer very short. -1.27e+05. What is the difference between the Number of enrolments of both sexes of Guam in 1975 and the Number of enrolments of both sexes of Switzerland in 1981?
Provide a succinct answer. -4.33e+05. What is the difference between the Number of enrolments of both sexes of Mongolia in 1975 and the Number of enrolments of both sexes of Switzerland in 1981?
Provide a short and direct response. -3.23e+05. What is the difference between the Number of enrolments of both sexes in South Asia in 1975 and the Number of enrolments of both sexes in Guam in 1982?
Your answer should be very brief. 8.09e+07. What is the difference between the Number of enrolments of both sexes in South Asia in 1975 and the Number of enrolments of both sexes in Mongolia in 1982?
Keep it short and to the point. 8.08e+07. What is the difference between the Number of enrolments of both sexes of South Asia in 1975 and the Number of enrolments of both sexes of Switzerland in 1982?
Ensure brevity in your answer.  8.05e+07. What is the difference between the Number of enrolments of both sexes in Guam in 1975 and the Number of enrolments of both sexes in Mongolia in 1982?
Offer a terse response. -1.29e+05. What is the difference between the Number of enrolments of both sexes of Guam in 1975 and the Number of enrolments of both sexes of Switzerland in 1982?
Your answer should be very brief. -4.16e+05. What is the difference between the Number of enrolments of both sexes of Mongolia in 1975 and the Number of enrolments of both sexes of Switzerland in 1982?
Ensure brevity in your answer.  -3.06e+05. What is the difference between the Number of enrolments of both sexes in South Asia in 1976 and the Number of enrolments of both sexes in Guam in 1979?
Offer a terse response. 8.24e+07. What is the difference between the Number of enrolments of both sexes of South Asia in 1976 and the Number of enrolments of both sexes of Mongolia in 1979?
Give a very brief answer. 8.23e+07. What is the difference between the Number of enrolments of both sexes of South Asia in 1976 and the Number of enrolments of both sexes of Switzerland in 1979?
Provide a succinct answer. 8.19e+07. What is the difference between the Number of enrolments of both sexes in Guam in 1976 and the Number of enrolments of both sexes in Mongolia in 1979?
Ensure brevity in your answer.  -1.18e+05. What is the difference between the Number of enrolments of both sexes in Guam in 1976 and the Number of enrolments of both sexes in Switzerland in 1979?
Make the answer very short. -4.66e+05. What is the difference between the Number of enrolments of both sexes of Mongolia in 1976 and the Number of enrolments of both sexes of Switzerland in 1979?
Keep it short and to the point. -3.56e+05. What is the difference between the Number of enrolments of both sexes in South Asia in 1976 and the Number of enrolments of both sexes in Guam in 1980?
Keep it short and to the point. 8.24e+07. What is the difference between the Number of enrolments of both sexes of South Asia in 1976 and the Number of enrolments of both sexes of Mongolia in 1980?
Your answer should be compact. 8.23e+07. What is the difference between the Number of enrolments of both sexes in South Asia in 1976 and the Number of enrolments of both sexes in Switzerland in 1980?
Keep it short and to the point. 8.20e+07. What is the difference between the Number of enrolments of both sexes in Guam in 1976 and the Number of enrolments of both sexes in Mongolia in 1980?
Give a very brief answer. -1.21e+05. What is the difference between the Number of enrolments of both sexes in Guam in 1976 and the Number of enrolments of both sexes in Switzerland in 1980?
Ensure brevity in your answer.  -4.48e+05. What is the difference between the Number of enrolments of both sexes of Mongolia in 1976 and the Number of enrolments of both sexes of Switzerland in 1980?
Keep it short and to the point. -3.39e+05. What is the difference between the Number of enrolments of both sexes of South Asia in 1976 and the Number of enrolments of both sexes of Guam in 1981?
Provide a short and direct response. 8.24e+07. What is the difference between the Number of enrolments of both sexes in South Asia in 1976 and the Number of enrolments of both sexes in Mongolia in 1981?
Offer a very short reply. 8.23e+07. What is the difference between the Number of enrolments of both sexes in South Asia in 1976 and the Number of enrolments of both sexes in Switzerland in 1981?
Your answer should be compact. 8.20e+07. What is the difference between the Number of enrolments of both sexes in Guam in 1976 and the Number of enrolments of both sexes in Mongolia in 1981?
Ensure brevity in your answer.  -1.25e+05. What is the difference between the Number of enrolments of both sexes of Guam in 1976 and the Number of enrolments of both sexes of Switzerland in 1981?
Your answer should be compact. -4.31e+05. What is the difference between the Number of enrolments of both sexes of Mongolia in 1976 and the Number of enrolments of both sexes of Switzerland in 1981?
Your answer should be very brief. -3.21e+05. What is the difference between the Number of enrolments of both sexes of South Asia in 1976 and the Number of enrolments of both sexes of Guam in 1982?
Make the answer very short. 8.24e+07. What is the difference between the Number of enrolments of both sexes in South Asia in 1976 and the Number of enrolments of both sexes in Mongolia in 1982?
Offer a very short reply. 8.23e+07. What is the difference between the Number of enrolments of both sexes in South Asia in 1976 and the Number of enrolments of both sexes in Switzerland in 1982?
Ensure brevity in your answer.  8.20e+07. What is the difference between the Number of enrolments of both sexes of Guam in 1976 and the Number of enrolments of both sexes of Mongolia in 1982?
Your answer should be very brief. -1.26e+05. What is the difference between the Number of enrolments of both sexes in Guam in 1976 and the Number of enrolments of both sexes in Switzerland in 1982?
Make the answer very short. -4.14e+05. What is the difference between the Number of enrolments of both sexes in Mongolia in 1976 and the Number of enrolments of both sexes in Switzerland in 1982?
Provide a short and direct response. -3.04e+05. What is the difference between the Number of enrolments of both sexes of South Asia in 1979 and the Number of enrolments of both sexes of Guam in 1980?
Offer a terse response. 8.59e+07. What is the difference between the Number of enrolments of both sexes of South Asia in 1979 and the Number of enrolments of both sexes of Mongolia in 1980?
Offer a terse response. 8.58e+07. What is the difference between the Number of enrolments of both sexes in South Asia in 1979 and the Number of enrolments of both sexes in Switzerland in 1980?
Your response must be concise. 8.55e+07. What is the difference between the Number of enrolments of both sexes of Guam in 1979 and the Number of enrolments of both sexes of Mongolia in 1980?
Provide a succinct answer. -1.24e+05. What is the difference between the Number of enrolments of both sexes of Guam in 1979 and the Number of enrolments of both sexes of Switzerland in 1980?
Make the answer very short. -4.51e+05. What is the difference between the Number of enrolments of both sexes of Mongolia in 1979 and the Number of enrolments of both sexes of Switzerland in 1980?
Keep it short and to the point. -3.30e+05. What is the difference between the Number of enrolments of both sexes in South Asia in 1979 and the Number of enrolments of both sexes in Guam in 1981?
Offer a very short reply. 8.59e+07. What is the difference between the Number of enrolments of both sexes in South Asia in 1979 and the Number of enrolments of both sexes in Mongolia in 1981?
Make the answer very short. 8.58e+07. What is the difference between the Number of enrolments of both sexes in South Asia in 1979 and the Number of enrolments of both sexes in Switzerland in 1981?
Your answer should be very brief. 8.55e+07. What is the difference between the Number of enrolments of both sexes in Guam in 1979 and the Number of enrolments of both sexes in Mongolia in 1981?
Make the answer very short. -1.27e+05. What is the difference between the Number of enrolments of both sexes in Guam in 1979 and the Number of enrolments of both sexes in Switzerland in 1981?
Provide a succinct answer. -4.33e+05. What is the difference between the Number of enrolments of both sexes in Mongolia in 1979 and the Number of enrolments of both sexes in Switzerland in 1981?
Your answer should be very brief. -3.12e+05. What is the difference between the Number of enrolments of both sexes in South Asia in 1979 and the Number of enrolments of both sexes in Guam in 1982?
Make the answer very short. 8.59e+07. What is the difference between the Number of enrolments of both sexes of South Asia in 1979 and the Number of enrolments of both sexes of Mongolia in 1982?
Provide a short and direct response. 8.58e+07. What is the difference between the Number of enrolments of both sexes in South Asia in 1979 and the Number of enrolments of both sexes in Switzerland in 1982?
Give a very brief answer. 8.55e+07. What is the difference between the Number of enrolments of both sexes in Guam in 1979 and the Number of enrolments of both sexes in Mongolia in 1982?
Give a very brief answer. -1.29e+05. What is the difference between the Number of enrolments of both sexes of Guam in 1979 and the Number of enrolments of both sexes of Switzerland in 1982?
Offer a terse response. -4.17e+05. What is the difference between the Number of enrolments of both sexes in Mongolia in 1979 and the Number of enrolments of both sexes in Switzerland in 1982?
Your answer should be very brief. -2.96e+05. What is the difference between the Number of enrolments of both sexes of South Asia in 1980 and the Number of enrolments of both sexes of Guam in 1981?
Provide a succinct answer. 8.88e+07. What is the difference between the Number of enrolments of both sexes in South Asia in 1980 and the Number of enrolments of both sexes in Mongolia in 1981?
Keep it short and to the point. 8.87e+07. What is the difference between the Number of enrolments of both sexes of South Asia in 1980 and the Number of enrolments of both sexes of Switzerland in 1981?
Offer a terse response. 8.84e+07. What is the difference between the Number of enrolments of both sexes of Guam in 1980 and the Number of enrolments of both sexes of Mongolia in 1981?
Your answer should be compact. -1.27e+05. What is the difference between the Number of enrolments of both sexes of Guam in 1980 and the Number of enrolments of both sexes of Switzerland in 1981?
Your answer should be very brief. -4.33e+05. What is the difference between the Number of enrolments of both sexes in Mongolia in 1980 and the Number of enrolments of both sexes in Switzerland in 1981?
Offer a very short reply. -3.10e+05. What is the difference between the Number of enrolments of both sexes of South Asia in 1980 and the Number of enrolments of both sexes of Guam in 1982?
Your answer should be very brief. 8.88e+07. What is the difference between the Number of enrolments of both sexes of South Asia in 1980 and the Number of enrolments of both sexes of Mongolia in 1982?
Offer a terse response. 8.87e+07. What is the difference between the Number of enrolments of both sexes in South Asia in 1980 and the Number of enrolments of both sexes in Switzerland in 1982?
Provide a succinct answer. 8.84e+07. What is the difference between the Number of enrolments of both sexes of Guam in 1980 and the Number of enrolments of both sexes of Mongolia in 1982?
Offer a terse response. -1.28e+05. What is the difference between the Number of enrolments of both sexes of Guam in 1980 and the Number of enrolments of both sexes of Switzerland in 1982?
Offer a very short reply. -4.16e+05. What is the difference between the Number of enrolments of both sexes of Mongolia in 1980 and the Number of enrolments of both sexes of Switzerland in 1982?
Give a very brief answer. -2.93e+05. What is the difference between the Number of enrolments of both sexes in South Asia in 1981 and the Number of enrolments of both sexes in Guam in 1982?
Your answer should be very brief. 9.22e+07. What is the difference between the Number of enrolments of both sexes of South Asia in 1981 and the Number of enrolments of both sexes of Mongolia in 1982?
Offer a very short reply. 9.21e+07. What is the difference between the Number of enrolments of both sexes in South Asia in 1981 and the Number of enrolments of both sexes in Switzerland in 1982?
Make the answer very short. 9.18e+07. What is the difference between the Number of enrolments of both sexes of Guam in 1981 and the Number of enrolments of both sexes of Mongolia in 1982?
Provide a succinct answer. -1.28e+05. What is the difference between the Number of enrolments of both sexes in Guam in 1981 and the Number of enrolments of both sexes in Switzerland in 1982?
Provide a succinct answer. -4.16e+05. What is the difference between the Number of enrolments of both sexes of Mongolia in 1981 and the Number of enrolments of both sexes of Switzerland in 1982?
Keep it short and to the point. -2.89e+05. What is the average Number of enrolments of both sexes in South Asia per year?
Make the answer very short. 8.50e+07. What is the average Number of enrolments of both sexes in Guam per year?
Your response must be concise. 1.84e+04. What is the average Number of enrolments of both sexes of Mongolia per year?
Keep it short and to the point. 1.35e+05. What is the average Number of enrolments of both sexes of Switzerland per year?
Your response must be concise. 5.10e+05. In the year 1973, what is the difference between the Number of enrolments of both sexes of South Asia and Number of enrolments of both sexes of Guam?
Provide a succinct answer. 7.73e+07. In the year 1973, what is the difference between the Number of enrolments of both sexes of South Asia and Number of enrolments of both sexes of Mongolia?
Give a very brief answer. 7.71e+07. In the year 1973, what is the difference between the Number of enrolments of both sexes of South Asia and Number of enrolments of both sexes of Switzerland?
Provide a succinct answer. 7.67e+07. In the year 1973, what is the difference between the Number of enrolments of both sexes of Guam and Number of enrolments of both sexes of Mongolia?
Give a very brief answer. -1.07e+05. In the year 1973, what is the difference between the Number of enrolments of both sexes of Guam and Number of enrolments of both sexes of Switzerland?
Provide a succinct answer. -5.39e+05. In the year 1973, what is the difference between the Number of enrolments of both sexes of Mongolia and Number of enrolments of both sexes of Switzerland?
Your answer should be very brief. -4.33e+05. In the year 1974, what is the difference between the Number of enrolments of both sexes of South Asia and Number of enrolments of both sexes of Guam?
Your response must be concise. 7.83e+07. In the year 1974, what is the difference between the Number of enrolments of both sexes of South Asia and Number of enrolments of both sexes of Mongolia?
Ensure brevity in your answer.  7.82e+07. In the year 1974, what is the difference between the Number of enrolments of both sexes in South Asia and Number of enrolments of both sexes in Switzerland?
Ensure brevity in your answer.  7.78e+07. In the year 1974, what is the difference between the Number of enrolments of both sexes of Guam and Number of enrolments of both sexes of Mongolia?
Ensure brevity in your answer.  -1.09e+05. In the year 1974, what is the difference between the Number of enrolments of both sexes in Guam and Number of enrolments of both sexes in Switzerland?
Make the answer very short. -5.43e+05. In the year 1974, what is the difference between the Number of enrolments of both sexes of Mongolia and Number of enrolments of both sexes of Switzerland?
Offer a very short reply. -4.35e+05. In the year 1975, what is the difference between the Number of enrolments of both sexes in South Asia and Number of enrolments of both sexes in Guam?
Your answer should be very brief. 8.09e+07. In the year 1975, what is the difference between the Number of enrolments of both sexes in South Asia and Number of enrolments of both sexes in Mongolia?
Give a very brief answer. 8.08e+07. In the year 1975, what is the difference between the Number of enrolments of both sexes of South Asia and Number of enrolments of both sexes of Switzerland?
Provide a succinct answer. 8.03e+07. In the year 1975, what is the difference between the Number of enrolments of both sexes of Guam and Number of enrolments of both sexes of Mongolia?
Keep it short and to the point. -1.10e+05. In the year 1975, what is the difference between the Number of enrolments of both sexes in Guam and Number of enrolments of both sexes in Switzerland?
Offer a very short reply. -5.44e+05. In the year 1975, what is the difference between the Number of enrolments of both sexes of Mongolia and Number of enrolments of both sexes of Switzerland?
Keep it short and to the point. -4.34e+05. In the year 1976, what is the difference between the Number of enrolments of both sexes of South Asia and Number of enrolments of both sexes of Guam?
Keep it short and to the point. 8.24e+07. In the year 1976, what is the difference between the Number of enrolments of both sexes in South Asia and Number of enrolments of both sexes in Mongolia?
Provide a succinct answer. 8.23e+07. In the year 1976, what is the difference between the Number of enrolments of both sexes in South Asia and Number of enrolments of both sexes in Switzerland?
Your answer should be very brief. 8.19e+07. In the year 1976, what is the difference between the Number of enrolments of both sexes of Guam and Number of enrolments of both sexes of Mongolia?
Keep it short and to the point. -1.10e+05. In the year 1976, what is the difference between the Number of enrolments of both sexes in Guam and Number of enrolments of both sexes in Switzerland?
Your answer should be compact. -5.37e+05. In the year 1976, what is the difference between the Number of enrolments of both sexes in Mongolia and Number of enrolments of both sexes in Switzerland?
Your answer should be very brief. -4.27e+05. In the year 1979, what is the difference between the Number of enrolments of both sexes of South Asia and Number of enrolments of both sexes of Guam?
Offer a very short reply. 8.59e+07. In the year 1979, what is the difference between the Number of enrolments of both sexes in South Asia and Number of enrolments of both sexes in Mongolia?
Provide a short and direct response. 8.58e+07. In the year 1979, what is the difference between the Number of enrolments of both sexes of South Asia and Number of enrolments of both sexes of Switzerland?
Offer a very short reply. 8.55e+07. In the year 1979, what is the difference between the Number of enrolments of both sexes in Guam and Number of enrolments of both sexes in Mongolia?
Provide a short and direct response. -1.21e+05. In the year 1979, what is the difference between the Number of enrolments of both sexes of Guam and Number of enrolments of both sexes of Switzerland?
Offer a terse response. -4.68e+05. In the year 1979, what is the difference between the Number of enrolments of both sexes in Mongolia and Number of enrolments of both sexes in Switzerland?
Provide a short and direct response. -3.47e+05. In the year 1980, what is the difference between the Number of enrolments of both sexes in South Asia and Number of enrolments of both sexes in Guam?
Make the answer very short. 8.88e+07. In the year 1980, what is the difference between the Number of enrolments of both sexes in South Asia and Number of enrolments of both sexes in Mongolia?
Provide a succinct answer. 8.87e+07. In the year 1980, what is the difference between the Number of enrolments of both sexes in South Asia and Number of enrolments of both sexes in Switzerland?
Offer a terse response. 8.83e+07. In the year 1980, what is the difference between the Number of enrolments of both sexes in Guam and Number of enrolments of both sexes in Mongolia?
Provide a short and direct response. -1.23e+05. In the year 1980, what is the difference between the Number of enrolments of both sexes in Guam and Number of enrolments of both sexes in Switzerland?
Provide a short and direct response. -4.50e+05. In the year 1980, what is the difference between the Number of enrolments of both sexes in Mongolia and Number of enrolments of both sexes in Switzerland?
Your answer should be very brief. -3.27e+05. In the year 1981, what is the difference between the Number of enrolments of both sexes of South Asia and Number of enrolments of both sexes of Guam?
Your response must be concise. 9.22e+07. In the year 1981, what is the difference between the Number of enrolments of both sexes in South Asia and Number of enrolments of both sexes in Mongolia?
Give a very brief answer. 9.21e+07. In the year 1981, what is the difference between the Number of enrolments of both sexes of South Asia and Number of enrolments of both sexes of Switzerland?
Your answer should be compact. 9.18e+07. In the year 1981, what is the difference between the Number of enrolments of both sexes of Guam and Number of enrolments of both sexes of Mongolia?
Your answer should be compact. -1.27e+05. In the year 1981, what is the difference between the Number of enrolments of both sexes of Guam and Number of enrolments of both sexes of Switzerland?
Make the answer very short. -4.33e+05. In the year 1981, what is the difference between the Number of enrolments of both sexes of Mongolia and Number of enrolments of both sexes of Switzerland?
Give a very brief answer. -3.06e+05. In the year 1982, what is the difference between the Number of enrolments of both sexes of South Asia and Number of enrolments of both sexes of Guam?
Offer a terse response. 9.43e+07. In the year 1982, what is the difference between the Number of enrolments of both sexes in South Asia and Number of enrolments of both sexes in Mongolia?
Offer a terse response. 9.42e+07. In the year 1982, what is the difference between the Number of enrolments of both sexes in South Asia and Number of enrolments of both sexes in Switzerland?
Ensure brevity in your answer.  9.39e+07. In the year 1982, what is the difference between the Number of enrolments of both sexes in Guam and Number of enrolments of both sexes in Mongolia?
Keep it short and to the point. -1.29e+05. In the year 1982, what is the difference between the Number of enrolments of both sexes in Guam and Number of enrolments of both sexes in Switzerland?
Your answer should be compact. -4.16e+05. In the year 1982, what is the difference between the Number of enrolments of both sexes of Mongolia and Number of enrolments of both sexes of Switzerland?
Offer a terse response. -2.88e+05. What is the ratio of the Number of enrolments of both sexes in South Asia in 1973 to that in 1974?
Ensure brevity in your answer.  0.99. What is the ratio of the Number of enrolments of both sexes in Guam in 1973 to that in 1974?
Ensure brevity in your answer.  1.01. What is the ratio of the Number of enrolments of both sexes of Mongolia in 1973 to that in 1974?
Give a very brief answer. 0.99. What is the ratio of the Number of enrolments of both sexes of Switzerland in 1973 to that in 1974?
Offer a terse response. 0.99. What is the ratio of the Number of enrolments of both sexes in South Asia in 1973 to that in 1975?
Keep it short and to the point. 0.96. What is the ratio of the Number of enrolments of both sexes in Guam in 1973 to that in 1975?
Keep it short and to the point. 1.05. What is the ratio of the Number of enrolments of both sexes of Mongolia in 1973 to that in 1975?
Offer a terse response. 0.98. What is the ratio of the Number of enrolments of both sexes of Guam in 1973 to that in 1976?
Make the answer very short. 0.92. What is the ratio of the Number of enrolments of both sexes in Mongolia in 1973 to that in 1976?
Keep it short and to the point. 0.96. What is the ratio of the Number of enrolments of both sexes of South Asia in 1973 to that in 1979?
Make the answer very short. 0.9. What is the ratio of the Number of enrolments of both sexes of Guam in 1973 to that in 1979?
Your answer should be very brief. 1.05. What is the ratio of the Number of enrolments of both sexes of Mongolia in 1973 to that in 1979?
Your answer should be very brief. 0.9. What is the ratio of the Number of enrolments of both sexes of Switzerland in 1973 to that in 1979?
Your answer should be very brief. 1.15. What is the ratio of the Number of enrolments of both sexes in South Asia in 1973 to that in 1980?
Provide a short and direct response. 0.87. What is the ratio of the Number of enrolments of both sexes in Guam in 1973 to that in 1980?
Your answer should be compact. 1.04. What is the ratio of the Number of enrolments of both sexes of Mongolia in 1973 to that in 1980?
Provide a succinct answer. 0.89. What is the ratio of the Number of enrolments of both sexes in Switzerland in 1973 to that in 1980?
Give a very brief answer. 1.19. What is the ratio of the Number of enrolments of both sexes of South Asia in 1973 to that in 1981?
Provide a succinct answer. 0.84. What is the ratio of the Number of enrolments of both sexes in Guam in 1973 to that in 1981?
Your response must be concise. 1.03. What is the ratio of the Number of enrolments of both sexes in Mongolia in 1973 to that in 1981?
Keep it short and to the point. 0.86. What is the ratio of the Number of enrolments of both sexes of Switzerland in 1973 to that in 1981?
Make the answer very short. 1.24. What is the ratio of the Number of enrolments of both sexes in South Asia in 1973 to that in 1982?
Your response must be concise. 0.82. What is the ratio of the Number of enrolments of both sexes in Guam in 1973 to that in 1982?
Ensure brevity in your answer.  1.04. What is the ratio of the Number of enrolments of both sexes in Mongolia in 1973 to that in 1982?
Offer a terse response. 0.85. What is the ratio of the Number of enrolments of both sexes in Switzerland in 1973 to that in 1982?
Offer a terse response. 1.28. What is the ratio of the Number of enrolments of both sexes in Guam in 1974 to that in 1975?
Your answer should be very brief. 1.04. What is the ratio of the Number of enrolments of both sexes of Mongolia in 1974 to that in 1975?
Your response must be concise. 0.99. What is the ratio of the Number of enrolments of both sexes in South Asia in 1974 to that in 1976?
Ensure brevity in your answer.  0.95. What is the ratio of the Number of enrolments of both sexes in Guam in 1974 to that in 1976?
Keep it short and to the point. 0.91. What is the ratio of the Number of enrolments of both sexes of Mongolia in 1974 to that in 1976?
Provide a succinct answer. 0.98. What is the ratio of the Number of enrolments of both sexes in Switzerland in 1974 to that in 1976?
Offer a terse response. 1.01. What is the ratio of the Number of enrolments of both sexes in South Asia in 1974 to that in 1979?
Keep it short and to the point. 0.91. What is the ratio of the Number of enrolments of both sexes of Guam in 1974 to that in 1979?
Your answer should be compact. 1.04. What is the ratio of the Number of enrolments of both sexes in Mongolia in 1974 to that in 1979?
Keep it short and to the point. 0.92. What is the ratio of the Number of enrolments of both sexes of Switzerland in 1974 to that in 1979?
Give a very brief answer. 1.16. What is the ratio of the Number of enrolments of both sexes of South Asia in 1974 to that in 1980?
Offer a very short reply. 0.88. What is the ratio of the Number of enrolments of both sexes of Guam in 1974 to that in 1980?
Provide a short and direct response. 1.02. What is the ratio of the Number of enrolments of both sexes in Mongolia in 1974 to that in 1980?
Make the answer very short. 0.9. What is the ratio of the Number of enrolments of both sexes of Switzerland in 1974 to that in 1980?
Keep it short and to the point. 1.2. What is the ratio of the Number of enrolments of both sexes of South Asia in 1974 to that in 1981?
Make the answer very short. 0.85. What is the ratio of the Number of enrolments of both sexes in Guam in 1974 to that in 1981?
Offer a very short reply. 1.02. What is the ratio of the Number of enrolments of both sexes of Mongolia in 1974 to that in 1981?
Keep it short and to the point. 0.88. What is the ratio of the Number of enrolments of both sexes in Switzerland in 1974 to that in 1981?
Your response must be concise. 1.25. What is the ratio of the Number of enrolments of both sexes in South Asia in 1974 to that in 1982?
Keep it short and to the point. 0.83. What is the ratio of the Number of enrolments of both sexes of Guam in 1974 to that in 1982?
Provide a succinct answer. 1.03. What is the ratio of the Number of enrolments of both sexes in Mongolia in 1974 to that in 1982?
Offer a terse response. 0.87. What is the ratio of the Number of enrolments of both sexes of Switzerland in 1974 to that in 1982?
Provide a succinct answer. 1.29. What is the ratio of the Number of enrolments of both sexes in South Asia in 1975 to that in 1976?
Make the answer very short. 0.98. What is the ratio of the Number of enrolments of both sexes in Guam in 1975 to that in 1976?
Keep it short and to the point. 0.88. What is the ratio of the Number of enrolments of both sexes in Mongolia in 1975 to that in 1976?
Give a very brief answer. 0.99. What is the ratio of the Number of enrolments of both sexes of Switzerland in 1975 to that in 1976?
Your answer should be compact. 1.01. What is the ratio of the Number of enrolments of both sexes of South Asia in 1975 to that in 1979?
Your response must be concise. 0.94. What is the ratio of the Number of enrolments of both sexes of Guam in 1975 to that in 1979?
Offer a terse response. 1. What is the ratio of the Number of enrolments of both sexes of Mongolia in 1975 to that in 1979?
Provide a succinct answer. 0.92. What is the ratio of the Number of enrolments of both sexes in Switzerland in 1975 to that in 1979?
Your response must be concise. 1.16. What is the ratio of the Number of enrolments of both sexes in South Asia in 1975 to that in 1980?
Your response must be concise. 0.91. What is the ratio of the Number of enrolments of both sexes of Guam in 1975 to that in 1980?
Keep it short and to the point. 0.99. What is the ratio of the Number of enrolments of both sexes in Mongolia in 1975 to that in 1980?
Provide a short and direct response. 0.91. What is the ratio of the Number of enrolments of both sexes of Switzerland in 1975 to that in 1980?
Provide a succinct answer. 1.2. What is the ratio of the Number of enrolments of both sexes of South Asia in 1975 to that in 1981?
Your answer should be compact. 0.88. What is the ratio of the Number of enrolments of both sexes of Guam in 1975 to that in 1981?
Your response must be concise. 0.98. What is the ratio of the Number of enrolments of both sexes of Mongolia in 1975 to that in 1981?
Provide a succinct answer. 0.88. What is the ratio of the Number of enrolments of both sexes in Switzerland in 1975 to that in 1981?
Ensure brevity in your answer.  1.25. What is the ratio of the Number of enrolments of both sexes of South Asia in 1975 to that in 1982?
Ensure brevity in your answer.  0.86. What is the ratio of the Number of enrolments of both sexes in Mongolia in 1975 to that in 1982?
Your answer should be compact. 0.87. What is the ratio of the Number of enrolments of both sexes of Switzerland in 1975 to that in 1982?
Ensure brevity in your answer.  1.29. What is the ratio of the Number of enrolments of both sexes of South Asia in 1976 to that in 1979?
Offer a terse response. 0.96. What is the ratio of the Number of enrolments of both sexes of Guam in 1976 to that in 1979?
Your answer should be very brief. 1.14. What is the ratio of the Number of enrolments of both sexes in Mongolia in 1976 to that in 1979?
Provide a succinct answer. 0.94. What is the ratio of the Number of enrolments of both sexes in Switzerland in 1976 to that in 1979?
Provide a succinct answer. 1.15. What is the ratio of the Number of enrolments of both sexes in South Asia in 1976 to that in 1980?
Offer a very short reply. 0.93. What is the ratio of the Number of enrolments of both sexes in Guam in 1976 to that in 1980?
Your answer should be compact. 1.12. What is the ratio of the Number of enrolments of both sexes in Mongolia in 1976 to that in 1980?
Your answer should be very brief. 0.92. What is the ratio of the Number of enrolments of both sexes in Switzerland in 1976 to that in 1980?
Give a very brief answer. 1.19. What is the ratio of the Number of enrolments of both sexes in South Asia in 1976 to that in 1981?
Your answer should be compact. 0.89. What is the ratio of the Number of enrolments of both sexes in Guam in 1976 to that in 1981?
Offer a very short reply. 1.12. What is the ratio of the Number of enrolments of both sexes of Mongolia in 1976 to that in 1981?
Your answer should be compact. 0.89. What is the ratio of the Number of enrolments of both sexes of Switzerland in 1976 to that in 1981?
Give a very brief answer. 1.23. What is the ratio of the Number of enrolments of both sexes of South Asia in 1976 to that in 1982?
Give a very brief answer. 0.87. What is the ratio of the Number of enrolments of both sexes of Guam in 1976 to that in 1982?
Your answer should be compact. 1.13. What is the ratio of the Number of enrolments of both sexes in Mongolia in 1976 to that in 1982?
Your answer should be compact. 0.89. What is the ratio of the Number of enrolments of both sexes of Switzerland in 1976 to that in 1982?
Your response must be concise. 1.28. What is the ratio of the Number of enrolments of both sexes of South Asia in 1979 to that in 1980?
Offer a very short reply. 0.97. What is the ratio of the Number of enrolments of both sexes of Guam in 1979 to that in 1980?
Your response must be concise. 0.98. What is the ratio of the Number of enrolments of both sexes of Mongolia in 1979 to that in 1980?
Ensure brevity in your answer.  0.98. What is the ratio of the Number of enrolments of both sexes in Switzerland in 1979 to that in 1980?
Keep it short and to the point. 1.04. What is the ratio of the Number of enrolments of both sexes in South Asia in 1979 to that in 1981?
Provide a short and direct response. 0.93. What is the ratio of the Number of enrolments of both sexes of Guam in 1979 to that in 1981?
Your response must be concise. 0.98. What is the ratio of the Number of enrolments of both sexes in Mongolia in 1979 to that in 1981?
Offer a terse response. 0.96. What is the ratio of the Number of enrolments of both sexes in Switzerland in 1979 to that in 1981?
Your answer should be very brief. 1.08. What is the ratio of the Number of enrolments of both sexes of South Asia in 1979 to that in 1982?
Offer a very short reply. 0.91. What is the ratio of the Number of enrolments of both sexes of Guam in 1979 to that in 1982?
Make the answer very short. 0.99. What is the ratio of the Number of enrolments of both sexes in Mongolia in 1979 to that in 1982?
Give a very brief answer. 0.95. What is the ratio of the Number of enrolments of both sexes of Switzerland in 1979 to that in 1982?
Provide a short and direct response. 1.12. What is the ratio of the Number of enrolments of both sexes of South Asia in 1980 to that in 1981?
Your answer should be very brief. 0.96. What is the ratio of the Number of enrolments of both sexes in Mongolia in 1980 to that in 1981?
Give a very brief answer. 0.97. What is the ratio of the Number of enrolments of both sexes of Switzerland in 1980 to that in 1981?
Provide a short and direct response. 1.04. What is the ratio of the Number of enrolments of both sexes of South Asia in 1980 to that in 1982?
Provide a short and direct response. 0.94. What is the ratio of the Number of enrolments of both sexes in Guam in 1980 to that in 1982?
Offer a terse response. 1.01. What is the ratio of the Number of enrolments of both sexes in Mongolia in 1980 to that in 1982?
Your answer should be very brief. 0.96. What is the ratio of the Number of enrolments of both sexes of Switzerland in 1980 to that in 1982?
Ensure brevity in your answer.  1.08. What is the ratio of the Number of enrolments of both sexes of South Asia in 1981 to that in 1982?
Offer a terse response. 0.98. What is the ratio of the Number of enrolments of both sexes in Guam in 1981 to that in 1982?
Keep it short and to the point. 1.01. What is the ratio of the Number of enrolments of both sexes of Switzerland in 1981 to that in 1982?
Give a very brief answer. 1.04. What is the difference between the highest and the second highest Number of enrolments of both sexes in South Asia?
Offer a terse response. 2.06e+06. What is the difference between the highest and the second highest Number of enrolments of both sexes in Guam?
Offer a terse response. 1542. What is the difference between the highest and the second highest Number of enrolments of both sexes in Mongolia?
Keep it short and to the point. 1300. What is the difference between the highest and the second highest Number of enrolments of both sexes of Switzerland?
Your response must be concise. 128. What is the difference between the highest and the lowest Number of enrolments of both sexes in South Asia?
Offer a terse response. 1.70e+07. What is the difference between the highest and the lowest Number of enrolments of both sexes of Guam?
Your answer should be very brief. 2471. What is the difference between the highest and the lowest Number of enrolments of both sexes in Mongolia?
Provide a succinct answer. 2.13e+04. What is the difference between the highest and the lowest Number of enrolments of both sexes of Switzerland?
Make the answer very short. 1.27e+05. 